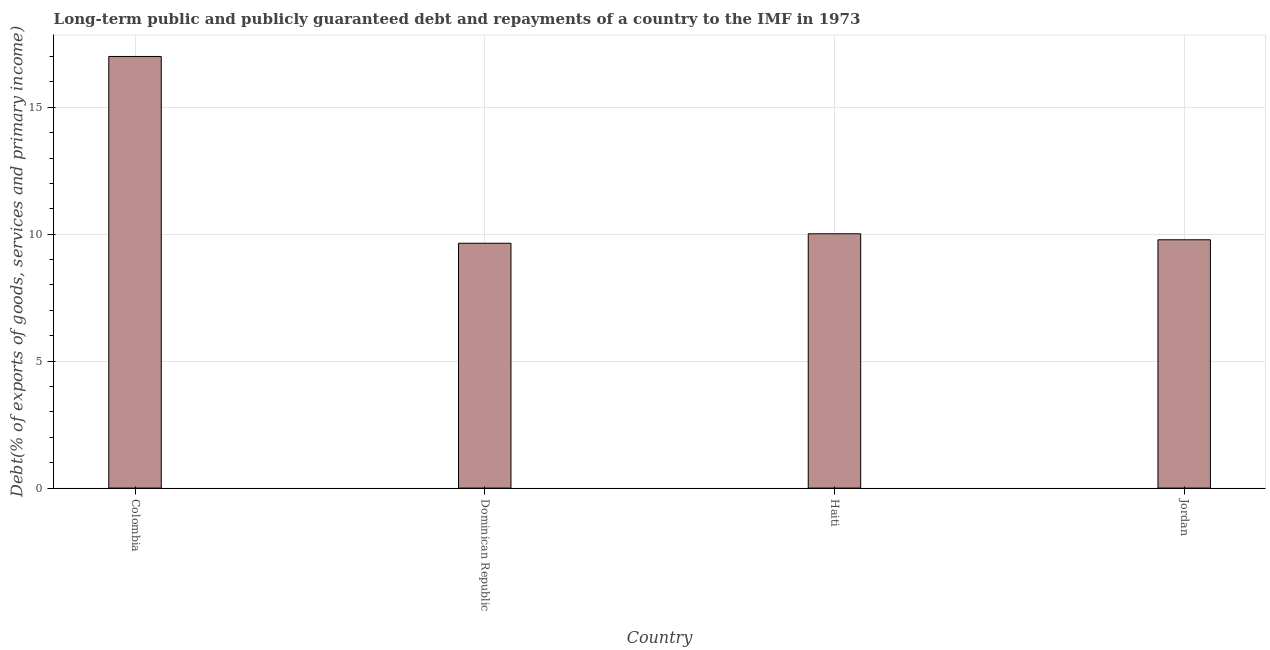Does the graph contain grids?
Keep it short and to the point. Yes. What is the title of the graph?
Offer a very short reply. Long-term public and publicly guaranteed debt and repayments of a country to the IMF in 1973. What is the label or title of the Y-axis?
Provide a short and direct response. Debt(% of exports of goods, services and primary income). What is the debt service in Colombia?
Keep it short and to the point. 17. Across all countries, what is the maximum debt service?
Your answer should be compact. 17. Across all countries, what is the minimum debt service?
Offer a very short reply. 9.64. In which country was the debt service maximum?
Make the answer very short. Colombia. In which country was the debt service minimum?
Offer a very short reply. Dominican Republic. What is the sum of the debt service?
Provide a succinct answer. 46.44. What is the difference between the debt service in Haiti and Jordan?
Your answer should be very brief. 0.24. What is the average debt service per country?
Offer a very short reply. 11.61. What is the median debt service?
Provide a succinct answer. 9.9. What is the ratio of the debt service in Dominican Republic to that in Jordan?
Offer a very short reply. 0.99. Is the difference between the debt service in Dominican Republic and Jordan greater than the difference between any two countries?
Provide a succinct answer. No. What is the difference between the highest and the second highest debt service?
Your response must be concise. 6.99. What is the difference between the highest and the lowest debt service?
Make the answer very short. 7.36. How many bars are there?
Make the answer very short. 4. What is the difference between two consecutive major ticks on the Y-axis?
Keep it short and to the point. 5. What is the Debt(% of exports of goods, services and primary income) of Colombia?
Give a very brief answer. 17. What is the Debt(% of exports of goods, services and primary income) of Dominican Republic?
Provide a succinct answer. 9.64. What is the Debt(% of exports of goods, services and primary income) in Haiti?
Make the answer very short. 10.02. What is the Debt(% of exports of goods, services and primary income) of Jordan?
Offer a very short reply. 9.78. What is the difference between the Debt(% of exports of goods, services and primary income) in Colombia and Dominican Republic?
Your response must be concise. 7.36. What is the difference between the Debt(% of exports of goods, services and primary income) in Colombia and Haiti?
Offer a very short reply. 6.98. What is the difference between the Debt(% of exports of goods, services and primary income) in Colombia and Jordan?
Provide a succinct answer. 7.22. What is the difference between the Debt(% of exports of goods, services and primary income) in Dominican Republic and Haiti?
Provide a short and direct response. -0.37. What is the difference between the Debt(% of exports of goods, services and primary income) in Dominican Republic and Jordan?
Make the answer very short. -0.14. What is the difference between the Debt(% of exports of goods, services and primary income) in Haiti and Jordan?
Keep it short and to the point. 0.24. What is the ratio of the Debt(% of exports of goods, services and primary income) in Colombia to that in Dominican Republic?
Offer a very short reply. 1.76. What is the ratio of the Debt(% of exports of goods, services and primary income) in Colombia to that in Haiti?
Make the answer very short. 1.7. What is the ratio of the Debt(% of exports of goods, services and primary income) in Colombia to that in Jordan?
Your response must be concise. 1.74. 